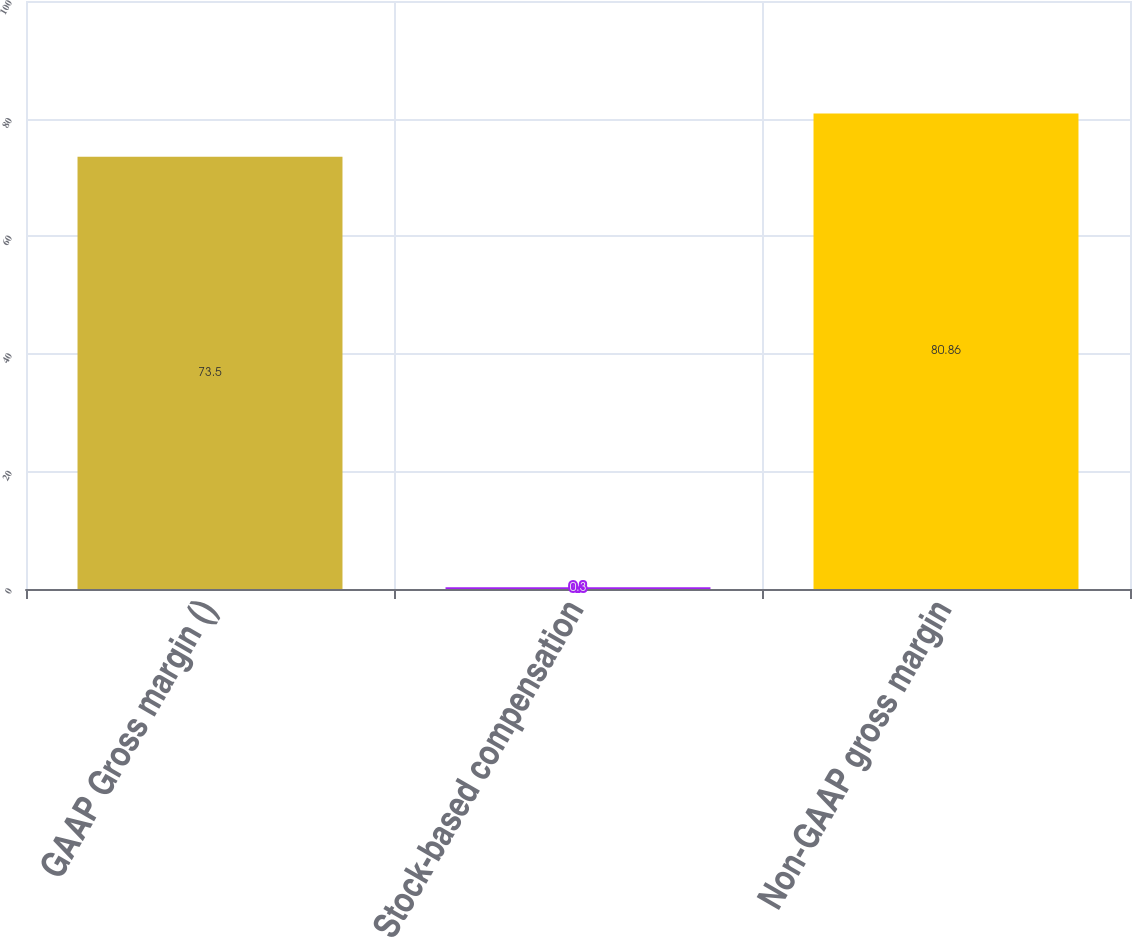Convert chart. <chart><loc_0><loc_0><loc_500><loc_500><bar_chart><fcel>GAAP Gross margin ()<fcel>Stock-based compensation<fcel>Non-GAAP gross margin<nl><fcel>73.5<fcel>0.3<fcel>80.86<nl></chart> 